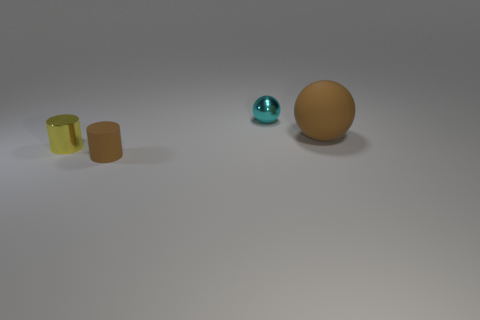Are there any small things behind the tiny metal sphere?
Make the answer very short. No. Do the yellow cylinder and the cyan shiny sphere have the same size?
Your answer should be compact. Yes. How many big brown things are the same material as the big ball?
Provide a succinct answer. 0. There is a shiny thing to the right of the cylinder to the left of the matte cylinder; what is its size?
Your answer should be compact. Small. There is a tiny thing that is on the right side of the yellow metal thing and in front of the cyan ball; what is its color?
Your answer should be compact. Brown. Do the small brown rubber thing and the tiny yellow metallic thing have the same shape?
Provide a short and direct response. Yes. What is the size of the cylinder that is the same color as the large sphere?
Provide a succinct answer. Small. There is a object that is behind the brown rubber object behind the small metal cylinder; what shape is it?
Offer a terse response. Sphere. Is the shape of the small cyan shiny thing the same as the tiny metal thing that is in front of the brown ball?
Offer a terse response. No. What color is the shiny object that is the same size as the cyan ball?
Your answer should be compact. Yellow. 